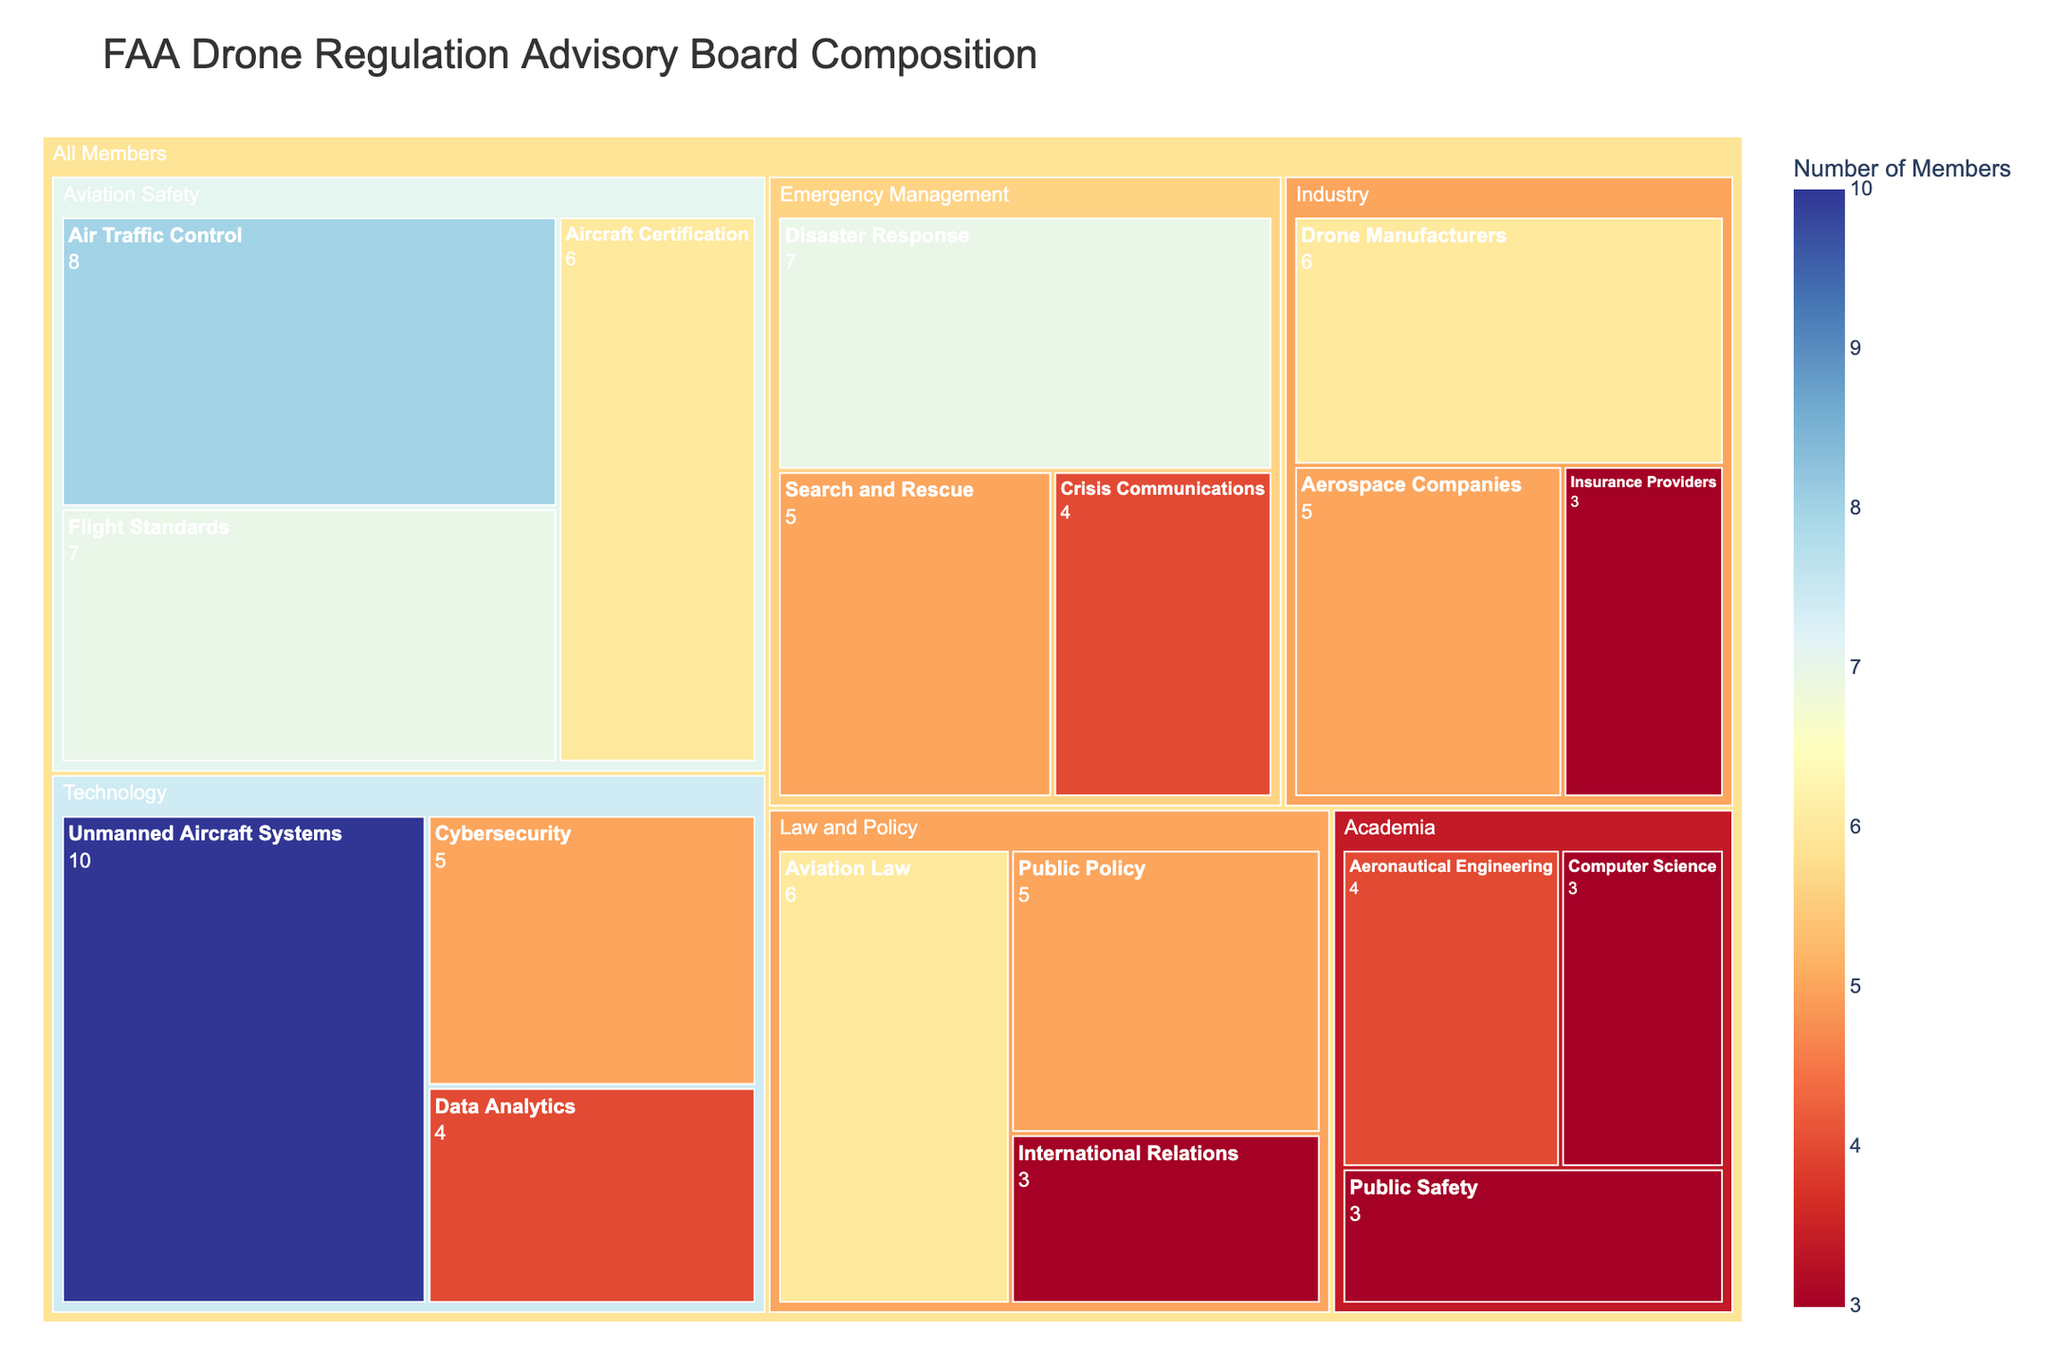What is the title of the figure? The title is usually displayed prominently at the top of the figure.
Answer: FAA Drone Regulation Advisory Board Composition How many members have expertise in Disaster Response? Locate the "Disaster Response" area in the treemap and check the number of members indicated.
Answer: 7 Which area has the most members? Compare the total members for each primary area (Aviation Safety, Technology, Law and Policy, etc.) and identify the one with the highest value.
Answer: Technology Combine the number of members with expertise in Aircraft Certification and Public Policy. Find the number of members for Aircraft Certification (6) and Public Policy (5), then add them together.
Answer: 11 Which expertise within the Aviation Safety area has the fewest members? Compare the members listed under each expertise in the Aviation Safety section: Air Traffic Control (8), Aircraft Certification (6), and Flight Standards (7).
Answer: Aircraft Certification How does the number of members in Cybersecurity compare to those in Search and Rescue? Find the number of members for Cybersecurity (5) and Search and Rescue (5), and compare them.
Answer: They are the same Which expertise has the highest number of members and what is the count? Check all expertise categories and identify the one with the highest number of members.
Answer: Unmanned Aircraft Systems, 10 Identify the area that has a member count equal to that of Drone Manufacturers. Locate the Drone Manufacturers in the Industry area (6) and find another area with 6 members: Aircraft Certification in Aviation Safety, and Aviation Law in Law and Policy.
Answer: Aircraft Certification and Aviation Law What is the combined total number of members from all expertise categories in the Law and Policy area? Sum up the members from each expertise in Law and Policy: Aviation Law (6), Public Policy (5), and International Relations (3).
Answer: 14 How many more members are there in the Unmanned Aircraft Systems expertise compared to Computer Science? Subtract the number of members in Computer Science (3) from that in Unmanned Aircraft Systems (10).
Answer: 7 